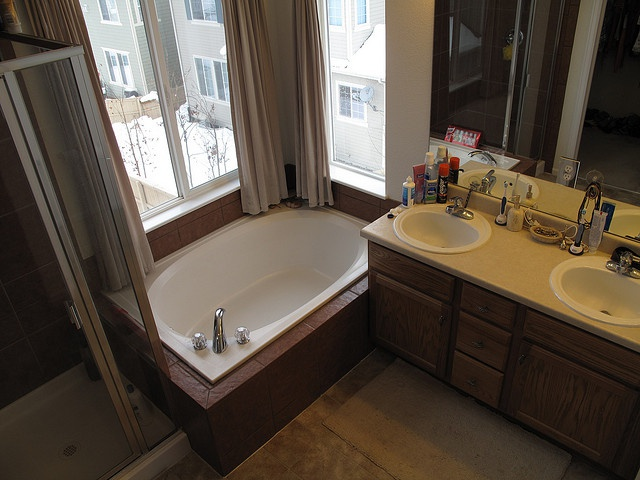Describe the objects in this image and their specific colors. I can see sink in black, olive, tan, and gray tones, sink in black, tan, gray, and olive tones, bottle in black, gray, and tan tones, bottle in black, maroon, and gray tones, and bottle in black, tan, blue, and gray tones in this image. 